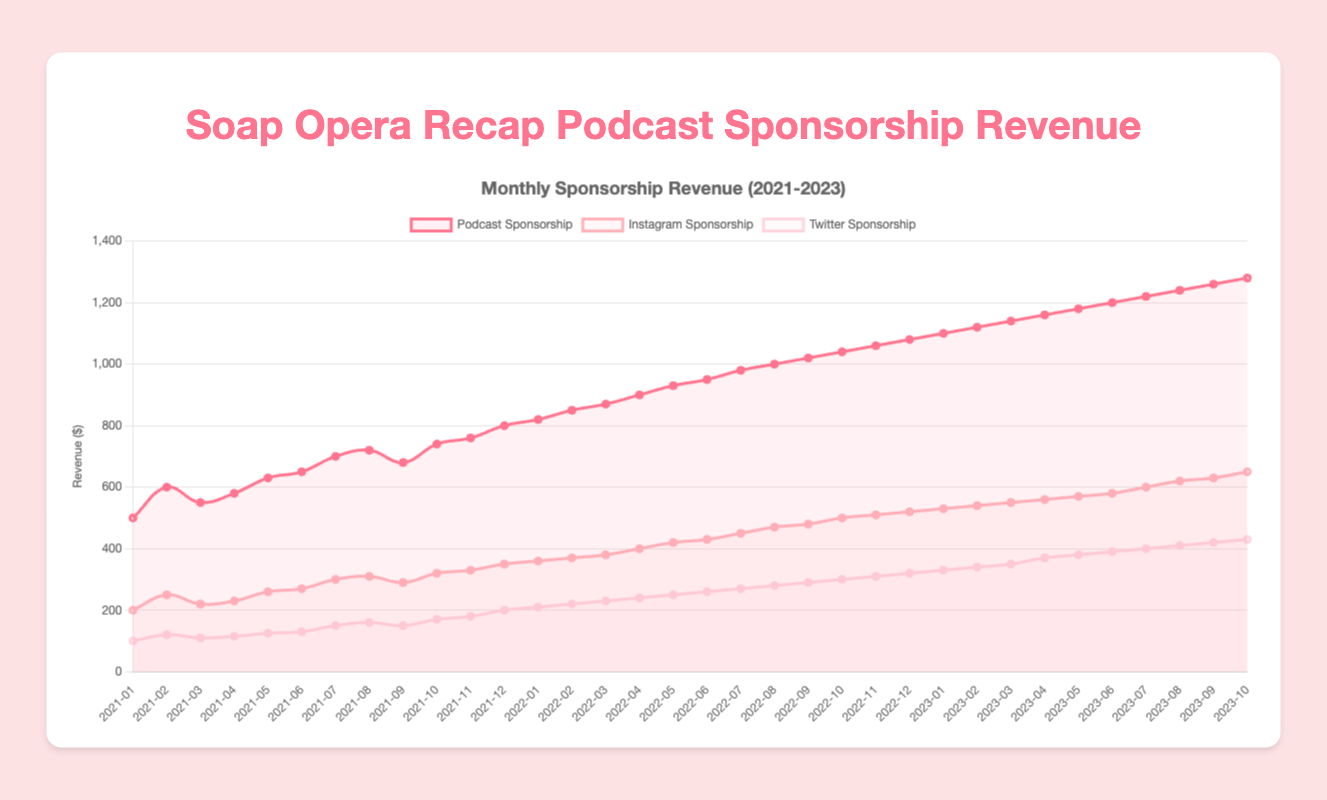What is the total sponsorship revenue for the podcast in the year 2022? To find the total podcast sponsorship revenue for 2022, we need to sum the monthly revenues of that year (January to December). So, the calculation will be 820+850+870+900+930+950+980+1000+1020+1040+1060+1080 = 11500
Answer: 11500 Which month in 2021 had the highest Instagram sponsorship revenue? To find the month with the highest Instagram sponsorship revenue in 2021, we look at the data points from January to December in 2021. The highest value for Instagram is 350, which occurs in December 2021.
Answer: December 2021 In which month did the Twitter sponsorship revenue first exceed 300 dollars? We observe the Twitter sponsorship values across the months until we see a value that exceeds 300. This first occurs in October 2022 with a value of 300.
Answer: October 2022 How much did the total sponsorship revenue (podcast, Instagram, and Twitter) grow from January 2021 to October 2023? First, we calculate the total revenue for January 2021 (500 + 200 + 100 = 800). Then, we calculate the total revenue for October 2023 (1280 + 650 + 430 = 2360). The growth is 2360 - 800 = 1560.
Answer: 1560 By what percentage did the podcast sponsorship revenue increase from November 2021 to December 2022? First, calculate the difference in podcast sponsorship revenue between November 2021 and December 2022 (1080 - 760 = 320). Next, find the percentage increase, which is (320/760) * 100 = 42.11%.
Answer: 42.11% Which platform showed the most consistent growth in sponsorship revenue from 2021 to 2023? We compare the lines' trend for podcast, Instagram, and Twitter sponsorships. The podcast sponsorship revenue shows a consistent upward trend with no decreases, indicating the most consistent growth.
Answer: Podcast sponsorship What's the highest monthly revenue achieved by any sponsorship platform from January 2021 to October 2023? We look for the highest value across all monthly revenues for the three platforms. The highest value is 1280 from podcast sponsorship in October 2023.
Answer: 1280 What is the average sponsorship revenue for Instagram in the first half of 2022? We need to sum the monthly Instagram revenues from January to June 2022 (360 + 370 + 380 + 400 + 420 + 430) = 2360. Next, we divide by the number of months (2360/6 = 393.33).
Answer: 393.33 How does the total sponsorship revenue for September 2023 compare to September 2022? First, calculate the total revenue for September 2023 (1260 + 630 + 420 = 2310) and September 2022 (1020 + 480 + 290 = 1790). Then compare the two totals (2310 - 1790 = 520).
Answer: 520 For which platform was the growth in sponsorship revenue from July 2022 to July 2023 the highest? First, calculate the growth for each platform: 
Podcast (1220 - 980 = 240), 
Instagram (600 - 450 = 150), 
Twitter (400 - 270 = 130). 
The highest growth is in the podcast sponsorship.
Answer: Podcast 